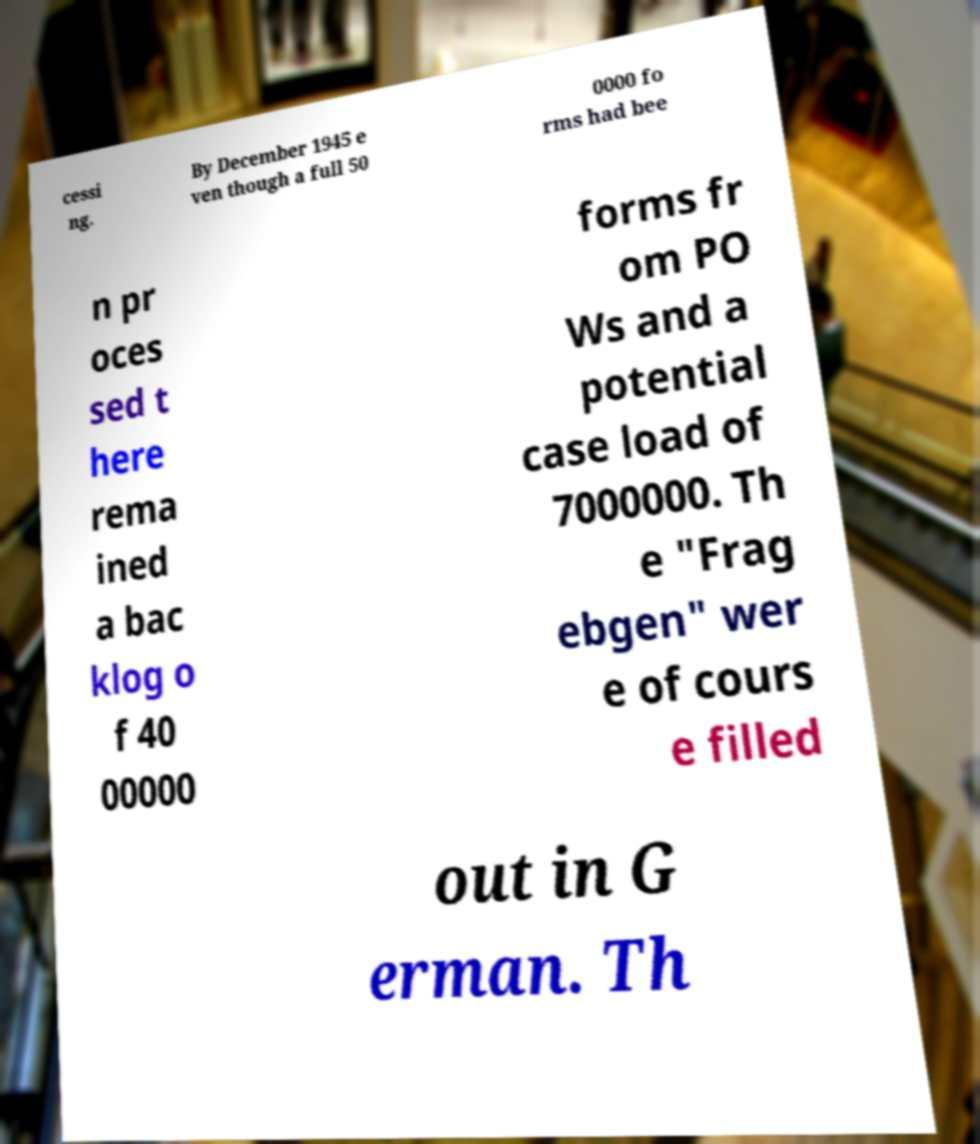Can you read and provide the text displayed in the image?This photo seems to have some interesting text. Can you extract and type it out for me? cessi ng. By December 1945 e ven though a full 50 0000 fo rms had bee n pr oces sed t here rema ined a bac klog o f 40 00000 forms fr om PO Ws and a potential case load of 7000000. Th e "Frag ebgen" wer e of cours e filled out in G erman. Th 